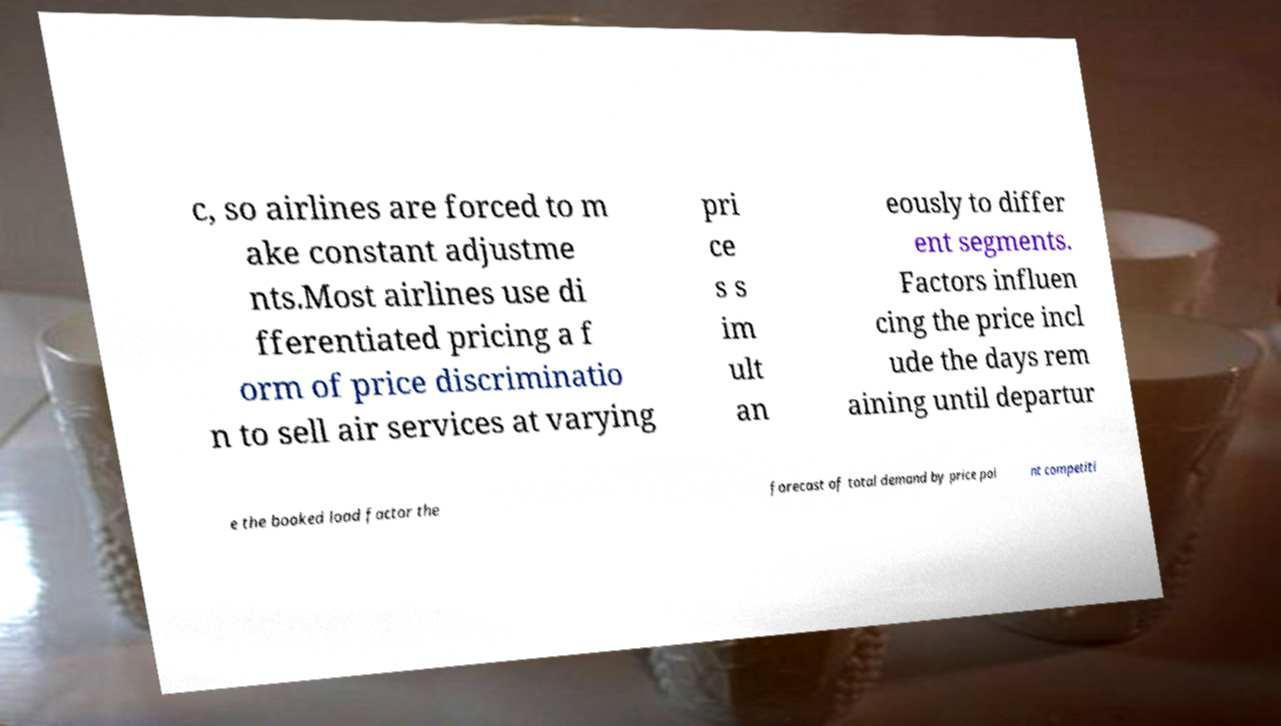Please identify and transcribe the text found in this image. c, so airlines are forced to m ake constant adjustme nts.Most airlines use di fferentiated pricing a f orm of price discriminatio n to sell air services at varying pri ce s s im ult an eously to differ ent segments. Factors influen cing the price incl ude the days rem aining until departur e the booked load factor the forecast of total demand by price poi nt competiti 